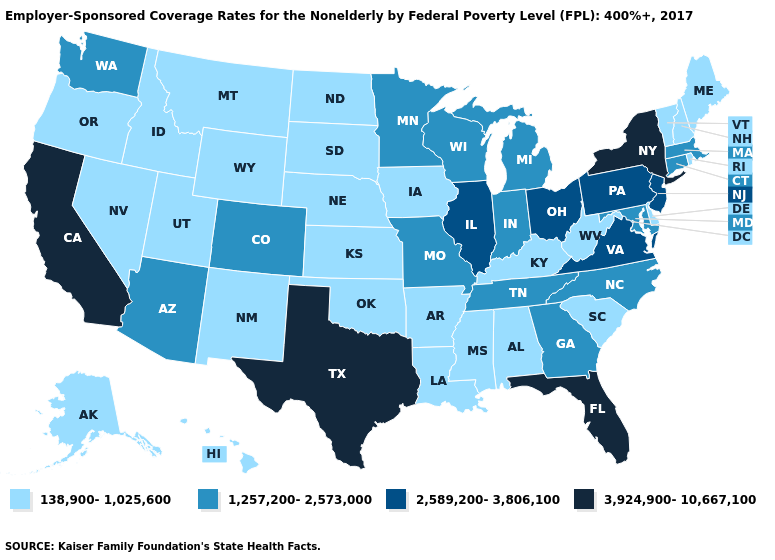Name the states that have a value in the range 3,924,900-10,667,100?
Answer briefly. California, Florida, New York, Texas. Which states have the lowest value in the USA?
Be succinct. Alabama, Alaska, Arkansas, Delaware, Hawaii, Idaho, Iowa, Kansas, Kentucky, Louisiana, Maine, Mississippi, Montana, Nebraska, Nevada, New Hampshire, New Mexico, North Dakota, Oklahoma, Oregon, Rhode Island, South Carolina, South Dakota, Utah, Vermont, West Virginia, Wyoming. Among the states that border New Jersey , which have the highest value?
Quick response, please. New York. Among the states that border Indiana , does Kentucky have the lowest value?
Short answer required. Yes. Which states have the lowest value in the USA?
Be succinct. Alabama, Alaska, Arkansas, Delaware, Hawaii, Idaho, Iowa, Kansas, Kentucky, Louisiana, Maine, Mississippi, Montana, Nebraska, Nevada, New Hampshire, New Mexico, North Dakota, Oklahoma, Oregon, Rhode Island, South Carolina, South Dakota, Utah, Vermont, West Virginia, Wyoming. Which states have the lowest value in the Northeast?
Keep it brief. Maine, New Hampshire, Rhode Island, Vermont. Among the states that border Nevada , which have the lowest value?
Short answer required. Idaho, Oregon, Utah. Does the map have missing data?
Concise answer only. No. What is the highest value in the Northeast ?
Answer briefly. 3,924,900-10,667,100. What is the lowest value in the USA?
Give a very brief answer. 138,900-1,025,600. What is the highest value in the USA?
Keep it brief. 3,924,900-10,667,100. Does Wisconsin have a higher value than Delaware?
Write a very short answer. Yes. Does Hawaii have a higher value than New York?
Answer briefly. No. Name the states that have a value in the range 138,900-1,025,600?
Keep it brief. Alabama, Alaska, Arkansas, Delaware, Hawaii, Idaho, Iowa, Kansas, Kentucky, Louisiana, Maine, Mississippi, Montana, Nebraska, Nevada, New Hampshire, New Mexico, North Dakota, Oklahoma, Oregon, Rhode Island, South Carolina, South Dakota, Utah, Vermont, West Virginia, Wyoming. What is the lowest value in the USA?
Give a very brief answer. 138,900-1,025,600. 